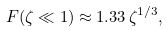<formula> <loc_0><loc_0><loc_500><loc_500>F ( \zeta \ll 1 ) \approx 1 . 3 3 \, \zeta ^ { 1 / 3 } ,</formula> 